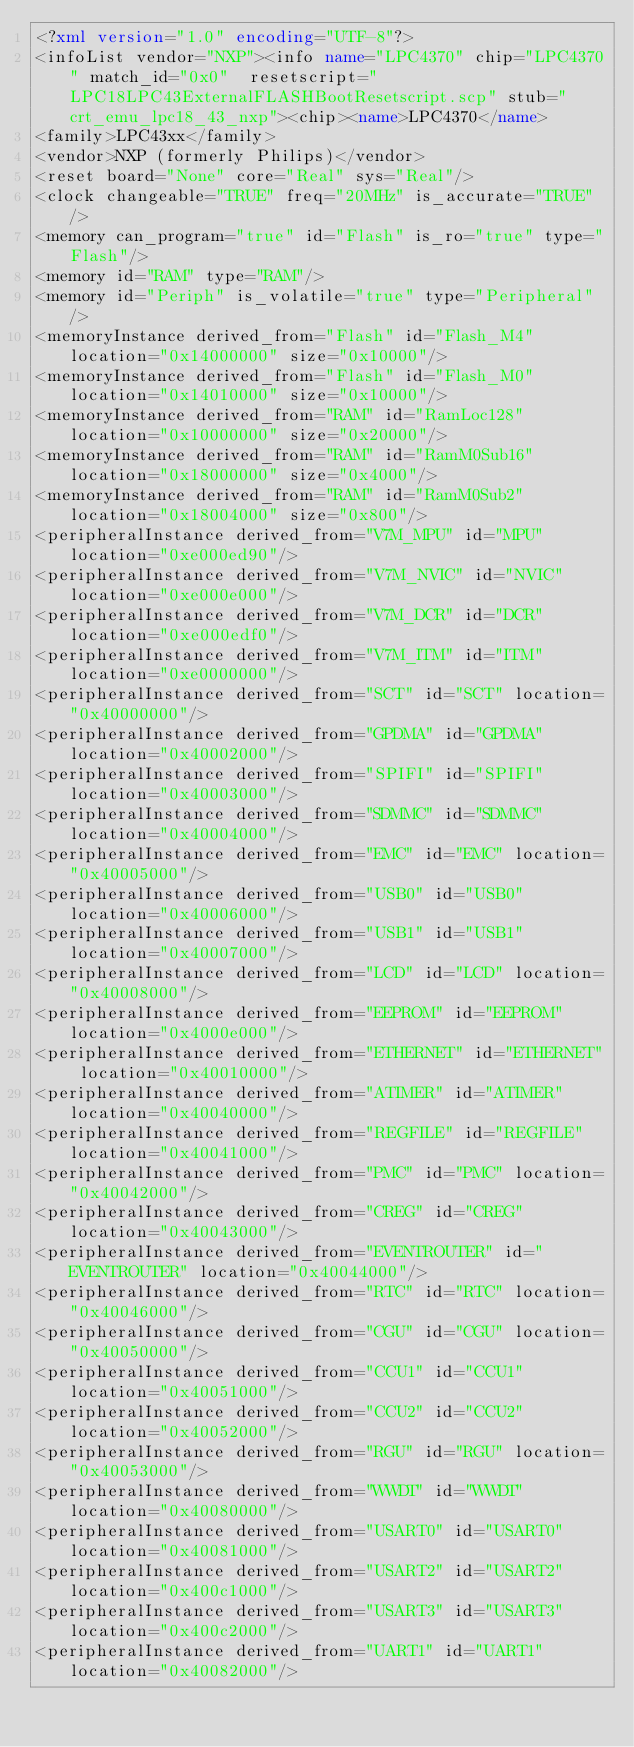<code> <loc_0><loc_0><loc_500><loc_500><_XML_><?xml version="1.0" encoding="UTF-8"?>
<infoList vendor="NXP"><info name="LPC4370" chip="LPC4370" match_id="0x0"  resetscript="LPC18LPC43ExternalFLASHBootResetscript.scp" stub="crt_emu_lpc18_43_nxp"><chip><name>LPC4370</name>
<family>LPC43xx</family>
<vendor>NXP (formerly Philips)</vendor>
<reset board="None" core="Real" sys="Real"/>
<clock changeable="TRUE" freq="20MHz" is_accurate="TRUE"/>
<memory can_program="true" id="Flash" is_ro="true" type="Flash"/>
<memory id="RAM" type="RAM"/>
<memory id="Periph" is_volatile="true" type="Peripheral"/>
<memoryInstance derived_from="Flash" id="Flash_M4" location="0x14000000" size="0x10000"/>
<memoryInstance derived_from="Flash" id="Flash_M0" location="0x14010000" size="0x10000"/>
<memoryInstance derived_from="RAM" id="RamLoc128" location="0x10000000" size="0x20000"/>
<memoryInstance derived_from="RAM" id="RamM0Sub16" location="0x18000000" size="0x4000"/>
<memoryInstance derived_from="RAM" id="RamM0Sub2" location="0x18004000" size="0x800"/>
<peripheralInstance derived_from="V7M_MPU" id="MPU" location="0xe000ed90"/>
<peripheralInstance derived_from="V7M_NVIC" id="NVIC" location="0xe000e000"/>
<peripheralInstance derived_from="V7M_DCR" id="DCR" location="0xe000edf0"/>
<peripheralInstance derived_from="V7M_ITM" id="ITM" location="0xe0000000"/>
<peripheralInstance derived_from="SCT" id="SCT" location="0x40000000"/>
<peripheralInstance derived_from="GPDMA" id="GPDMA" location="0x40002000"/>
<peripheralInstance derived_from="SPIFI" id="SPIFI" location="0x40003000"/>
<peripheralInstance derived_from="SDMMC" id="SDMMC" location="0x40004000"/>
<peripheralInstance derived_from="EMC" id="EMC" location="0x40005000"/>
<peripheralInstance derived_from="USB0" id="USB0" location="0x40006000"/>
<peripheralInstance derived_from="USB1" id="USB1" location="0x40007000"/>
<peripheralInstance derived_from="LCD" id="LCD" location="0x40008000"/>
<peripheralInstance derived_from="EEPROM" id="EEPROM" location="0x4000e000"/>
<peripheralInstance derived_from="ETHERNET" id="ETHERNET" location="0x40010000"/>
<peripheralInstance derived_from="ATIMER" id="ATIMER" location="0x40040000"/>
<peripheralInstance derived_from="REGFILE" id="REGFILE" location="0x40041000"/>
<peripheralInstance derived_from="PMC" id="PMC" location="0x40042000"/>
<peripheralInstance derived_from="CREG" id="CREG" location="0x40043000"/>
<peripheralInstance derived_from="EVENTROUTER" id="EVENTROUTER" location="0x40044000"/>
<peripheralInstance derived_from="RTC" id="RTC" location="0x40046000"/>
<peripheralInstance derived_from="CGU" id="CGU" location="0x40050000"/>
<peripheralInstance derived_from="CCU1" id="CCU1" location="0x40051000"/>
<peripheralInstance derived_from="CCU2" id="CCU2" location="0x40052000"/>
<peripheralInstance derived_from="RGU" id="RGU" location="0x40053000"/>
<peripheralInstance derived_from="WWDT" id="WWDT" location="0x40080000"/>
<peripheralInstance derived_from="USART0" id="USART0" location="0x40081000"/>
<peripheralInstance derived_from="USART2" id="USART2" location="0x400c1000"/>
<peripheralInstance derived_from="USART3" id="USART3" location="0x400c2000"/>
<peripheralInstance derived_from="UART1" id="UART1" location="0x40082000"/></code> 